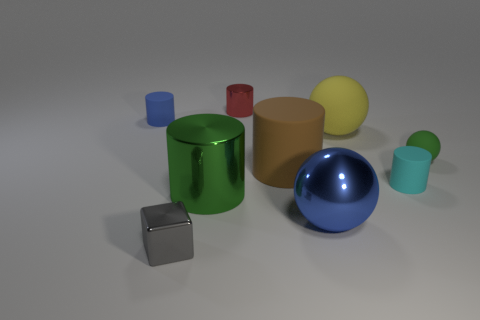Subtract all tiny spheres. How many spheres are left? 2 Subtract all green spheres. How many spheres are left? 2 Subtract 5 cylinders. How many cylinders are left? 0 Subtract all cylinders. How many objects are left? 4 Add 2 cubes. How many cubes exist? 3 Add 1 tiny brown cubes. How many objects exist? 10 Subtract 0 red cubes. How many objects are left? 9 Subtract all purple cylinders. Subtract all blue blocks. How many cylinders are left? 5 Subtract all small gray cubes. Subtract all large gray cylinders. How many objects are left? 8 Add 9 yellow matte balls. How many yellow matte balls are left? 10 